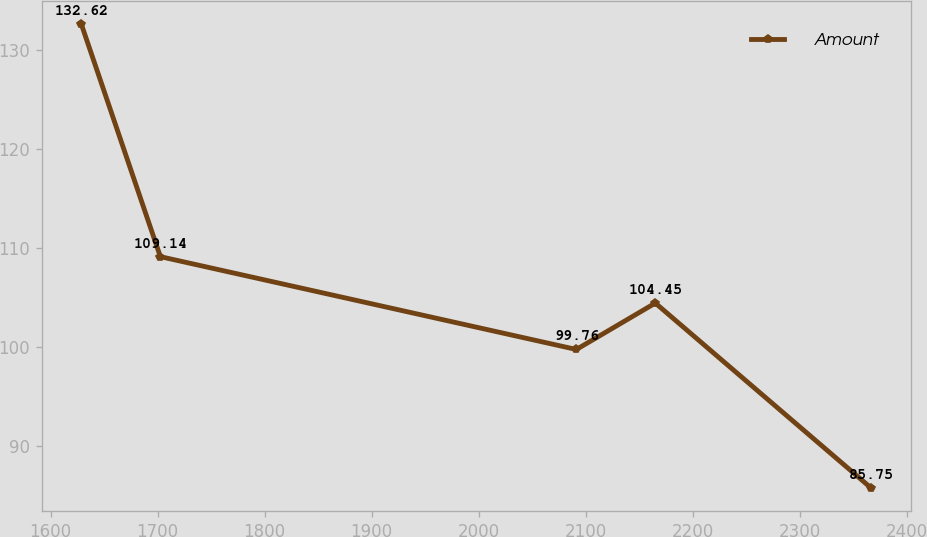<chart> <loc_0><loc_0><loc_500><loc_500><line_chart><ecel><fcel>Amount<nl><fcel>1628.85<fcel>132.62<nl><fcel>1702.64<fcel>109.14<nl><fcel>2091.28<fcel>99.76<nl><fcel>2165.07<fcel>104.45<nl><fcel>2366.78<fcel>85.75<nl></chart> 